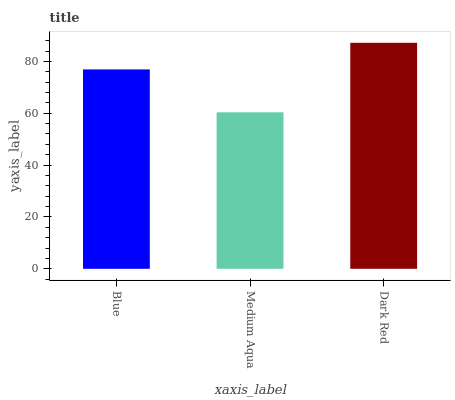Is Dark Red the minimum?
Answer yes or no. No. Is Medium Aqua the maximum?
Answer yes or no. No. Is Dark Red greater than Medium Aqua?
Answer yes or no. Yes. Is Medium Aqua less than Dark Red?
Answer yes or no. Yes. Is Medium Aqua greater than Dark Red?
Answer yes or no. No. Is Dark Red less than Medium Aqua?
Answer yes or no. No. Is Blue the high median?
Answer yes or no. Yes. Is Blue the low median?
Answer yes or no. Yes. Is Medium Aqua the high median?
Answer yes or no. No. Is Dark Red the low median?
Answer yes or no. No. 